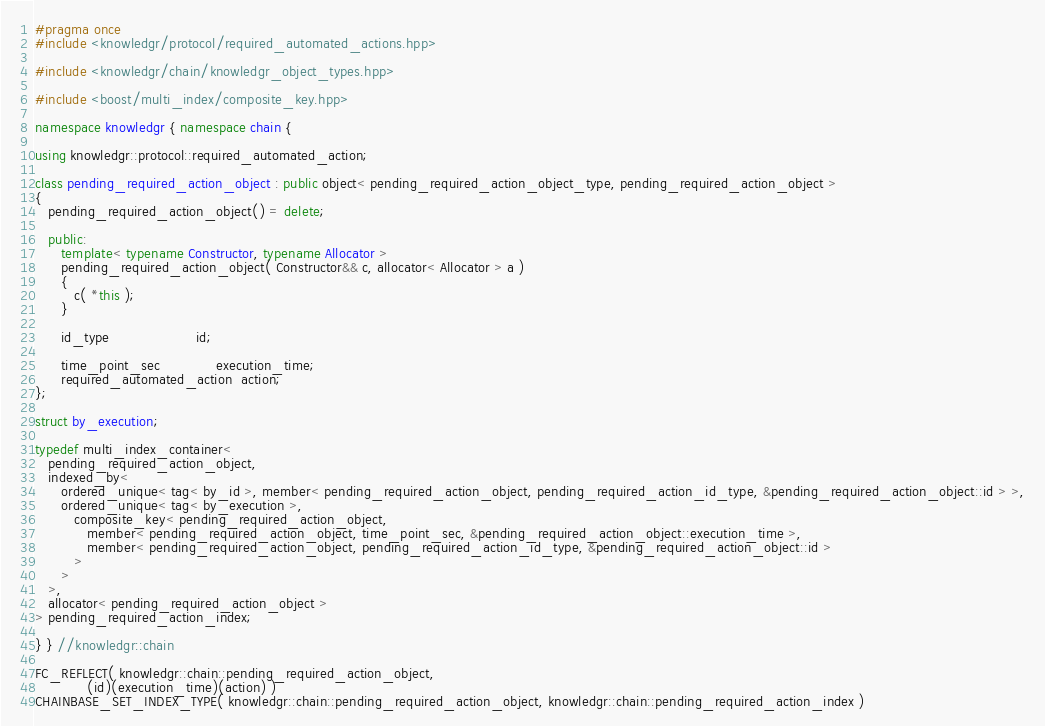Convert code to text. <code><loc_0><loc_0><loc_500><loc_500><_C++_>#pragma once
#include <knowledgr/protocol/required_automated_actions.hpp>

#include <knowledgr/chain/knowledgr_object_types.hpp>

#include <boost/multi_index/composite_key.hpp>

namespace knowledgr { namespace chain {

using knowledgr::protocol::required_automated_action;

class pending_required_action_object : public object< pending_required_action_object_type, pending_required_action_object >
{
   pending_required_action_object() = delete;

   public:
      template< typename Constructor, typename Allocator >
      pending_required_action_object( Constructor&& c, allocator< Allocator > a )
      {
         c( *this );
      }

      id_type                    id;

      time_point_sec             execution_time;
      required_automated_action  action;
};

struct by_execution;

typedef multi_index_container<
   pending_required_action_object,
   indexed_by<
      ordered_unique< tag< by_id >, member< pending_required_action_object, pending_required_action_id_type, &pending_required_action_object::id > >,
      ordered_unique< tag< by_execution >,
         composite_key< pending_required_action_object,
            member< pending_required_action_object, time_point_sec, &pending_required_action_object::execution_time >,
            member< pending_required_action_object, pending_required_action_id_type, &pending_required_action_object::id >
         >
      >
   >,
   allocator< pending_required_action_object >
> pending_required_action_index;

} } //knowledgr::chain

FC_REFLECT( knowledgr::chain::pending_required_action_object,
            (id)(execution_time)(action) )
CHAINBASE_SET_INDEX_TYPE( knowledgr::chain::pending_required_action_object, knowledgr::chain::pending_required_action_index )
</code> 